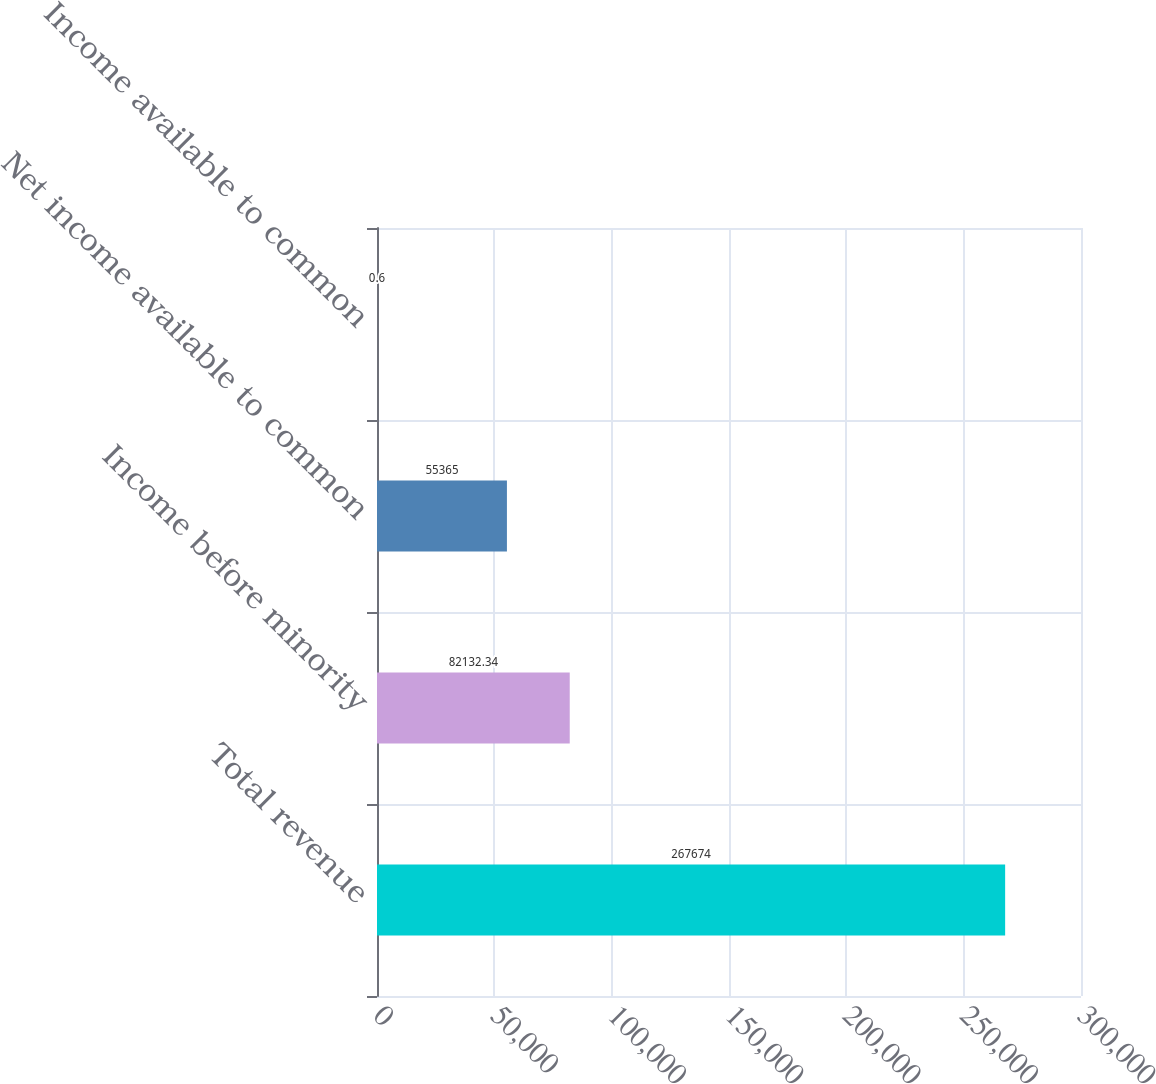Convert chart. <chart><loc_0><loc_0><loc_500><loc_500><bar_chart><fcel>Total revenue<fcel>Income before minority<fcel>Net income available to common<fcel>Income available to common<nl><fcel>267674<fcel>82132.3<fcel>55365<fcel>0.6<nl></chart> 